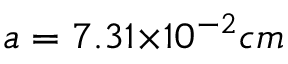Convert formula to latex. <formula><loc_0><loc_0><loc_500><loc_500>a = 7 . 3 1 { \times } 1 0 ^ { - 2 } c m</formula> 